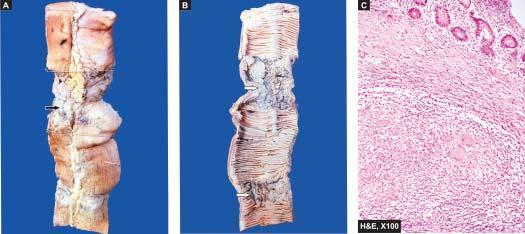does the margin show stricture and a lymph node in section having caseation necrosiss?
Answer the question using a single word or phrase. No 